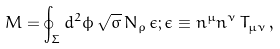Convert formula to latex. <formula><loc_0><loc_0><loc_500><loc_500>M = \oint _ { \Sigma } d ^ { 2 } \phi \, \sqrt { \sigma } \, N _ { \rho } \, \epsilon ; \epsilon \equiv n ^ { \mu } n ^ { \nu } \, T _ { \mu \nu } \, ,</formula> 